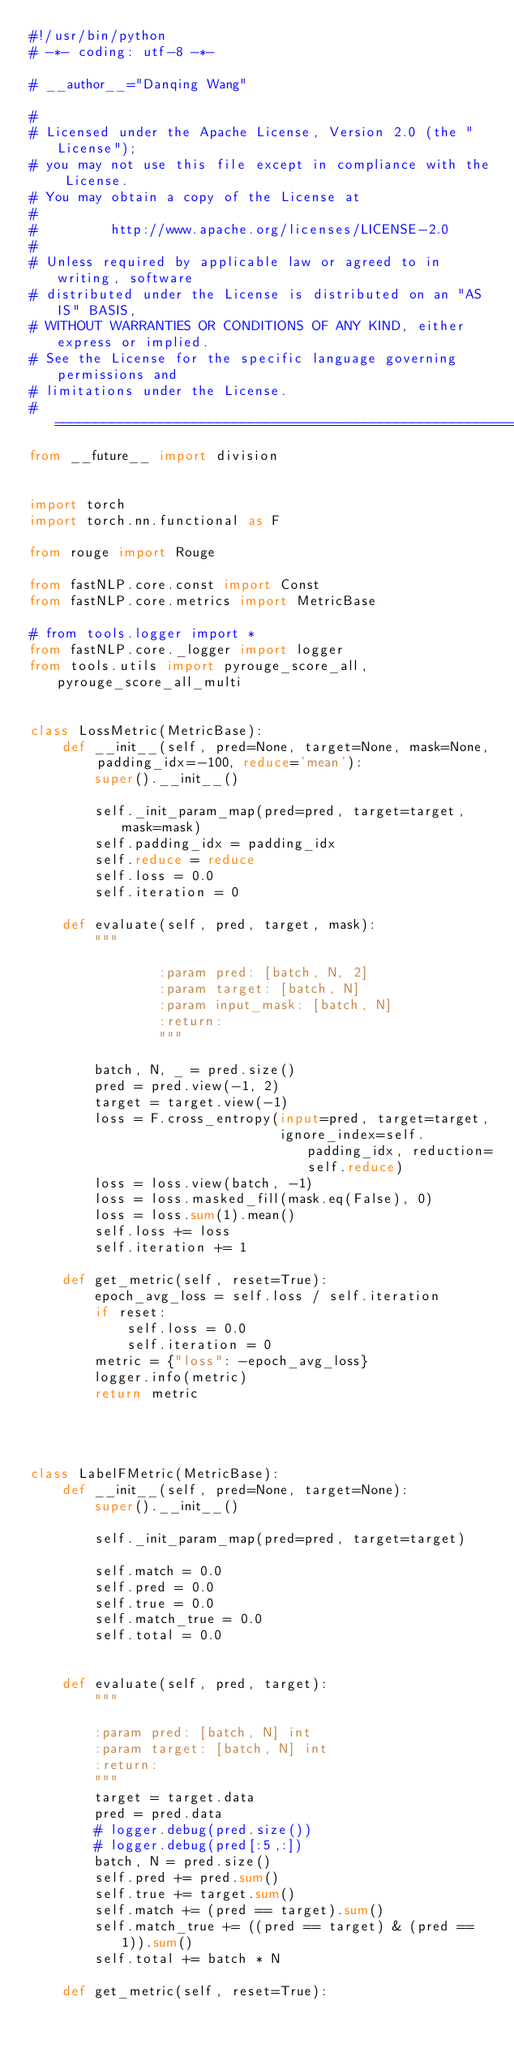Convert code to text. <code><loc_0><loc_0><loc_500><loc_500><_Python_>#!/usr/bin/python
# -*- coding: utf-8 -*-

# __author__="Danqing Wang"

#
# Licensed under the Apache License, Version 2.0 (the "License");
# you may not use this file except in compliance with the License.
# You may obtain a copy of the License at
#
#         http://www.apache.org/licenses/LICENSE-2.0
#
# Unless required by applicable law or agreed to in writing, software
# distributed under the License is distributed on an "AS IS" BASIS,
# WITHOUT WARRANTIES OR CONDITIONS OF ANY KIND, either express or implied.
# See the License for the specific language governing permissions and
# limitations under the License.
# ==============================================================================
from __future__ import division


import torch
import torch.nn.functional as F

from rouge import Rouge

from fastNLP.core.const import Const
from fastNLP.core.metrics import MetricBase

# from tools.logger import *
from fastNLP.core._logger import logger
from tools.utils import pyrouge_score_all, pyrouge_score_all_multi


class LossMetric(MetricBase):
    def __init__(self, pred=None, target=None, mask=None, padding_idx=-100, reduce='mean'):
        super().__init__()

        self._init_param_map(pred=pred, target=target, mask=mask)
        self.padding_idx = padding_idx
        self.reduce = reduce
        self.loss = 0.0
        self.iteration = 0

    def evaluate(self, pred, target, mask):
        """

                :param pred: [batch, N, 2]
                :param target: [batch, N]
                :param input_mask: [batch, N]
                :return: 
                """

        batch, N, _ = pred.size()
        pred = pred.view(-1, 2)
        target = target.view(-1)
        loss = F.cross_entropy(input=pred, target=target,
                               ignore_index=self.padding_idx, reduction=self.reduce)
        loss = loss.view(batch, -1)
        loss = loss.masked_fill(mask.eq(False), 0)
        loss = loss.sum(1).mean()
        self.loss += loss
        self.iteration += 1

    def get_metric(self, reset=True):
        epoch_avg_loss = self.loss / self.iteration
        if reset:
            self.loss = 0.0
            self.iteration = 0
        metric = {"loss": -epoch_avg_loss}
        logger.info(metric)
        return metric




class LabelFMetric(MetricBase):
    def __init__(self, pred=None, target=None):
        super().__init__()

        self._init_param_map(pred=pred, target=target)

        self.match = 0.0
        self.pred = 0.0
        self.true = 0.0
        self.match_true = 0.0
        self.total = 0.0


    def evaluate(self, pred, target):
        """
        
        :param pred: [batch, N] int
        :param target: [batch, N] int
        :return: 
        """
        target = target.data
        pred = pred.data
        # logger.debug(pred.size())
        # logger.debug(pred[:5,:])
        batch, N = pred.size()
        self.pred += pred.sum()
        self.true += target.sum()
        self.match += (pred == target).sum()
        self.match_true += ((pred == target) & (pred == 1)).sum()
        self.total += batch * N

    def get_metric(self, reset=True):</code> 